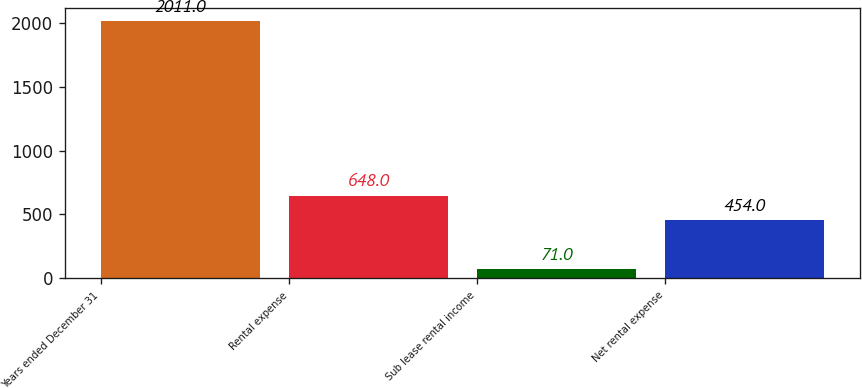<chart> <loc_0><loc_0><loc_500><loc_500><bar_chart><fcel>Years ended December 31<fcel>Rental expense<fcel>Sub lease rental income<fcel>Net rental expense<nl><fcel>2011<fcel>648<fcel>71<fcel>454<nl></chart> 